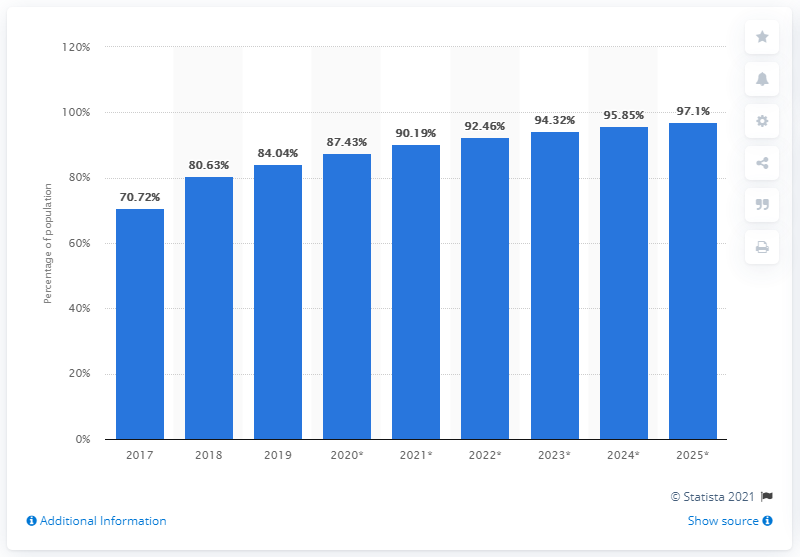Specify some key components in this picture. In 2019, 84.04% of Saudi Arabia's population accessed the internet from their mobile devices. 